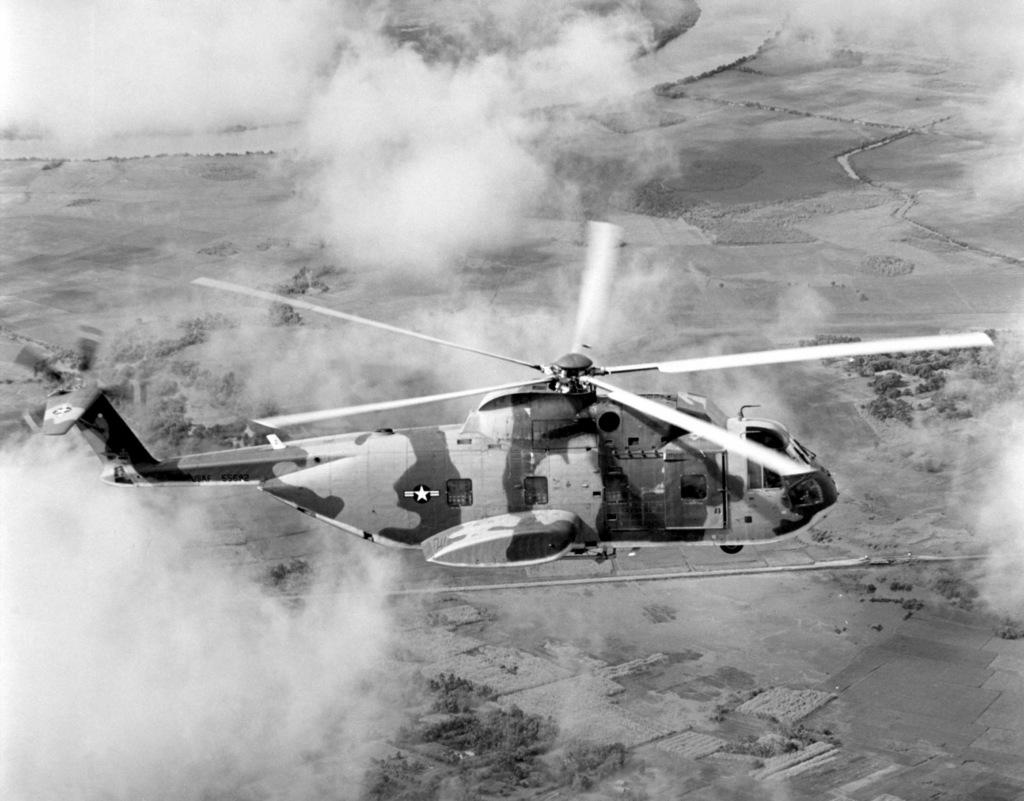What is the main subject of the image? The main subject of the image is a helicopter. What is the helicopter doing in the image? The helicopter is flying in the air. What can be seen below the helicopter in the image? There is ground visible at the bottom of the image. What is the condition of the air around the helicopter? There is smoke around the helicopter. What type of badge can be seen on the face of the helicopter in the image? There is no badge or face present on the helicopter in the image. What type of coil is visible on the helicopter in the image? There is no coil visible on the helicopter in the image. 